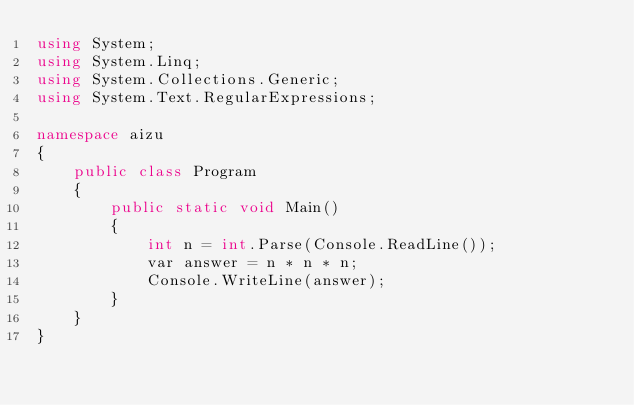Convert code to text. <code><loc_0><loc_0><loc_500><loc_500><_C#_>using System;
using System.Linq;
using System.Collections.Generic;
using System.Text.RegularExpressions;

namespace aizu
{
    public class Program
    {
        public static void Main()
        {
            int n = int.Parse(Console.ReadLine());
            var answer = n * n * n;
            Console.WriteLine(answer);
        }
    }
}</code> 